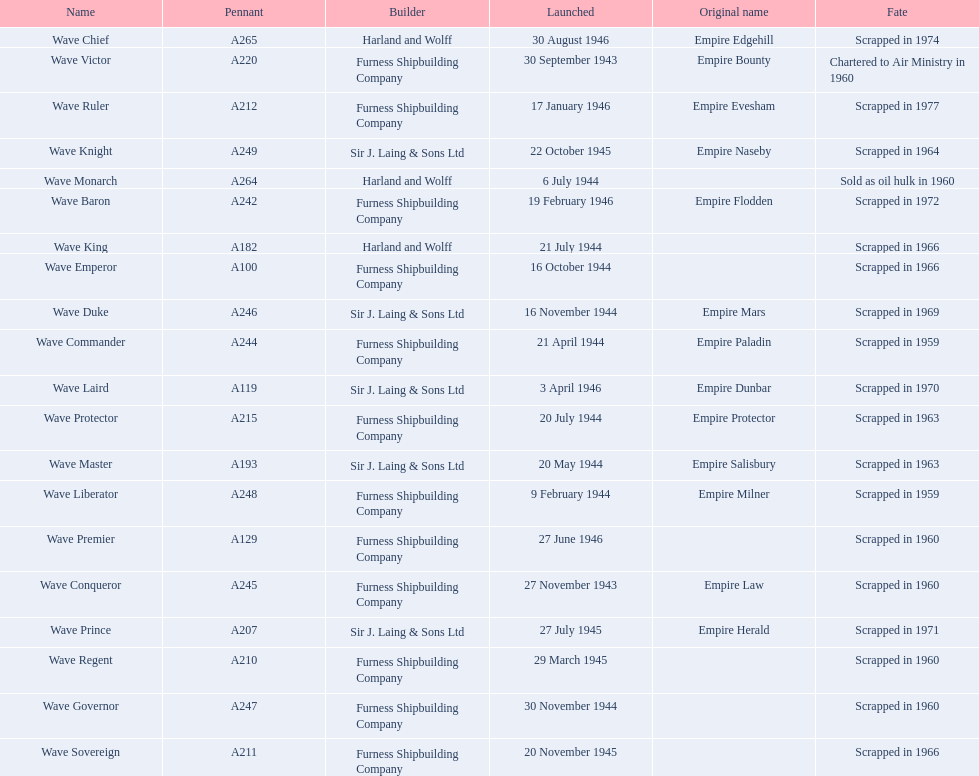What builders launched ships in november of any year? Furness Shipbuilding Company, Sir J. Laing & Sons Ltd, Furness Shipbuilding Company, Furness Shipbuilding Company. What ship builders ships had their original name's changed prior to scrapping? Furness Shipbuilding Company, Sir J. Laing & Sons Ltd. What was the name of the ship that was built in november and had its name changed prior to scrapping only 12 years after its launch? Wave Conqueror. 